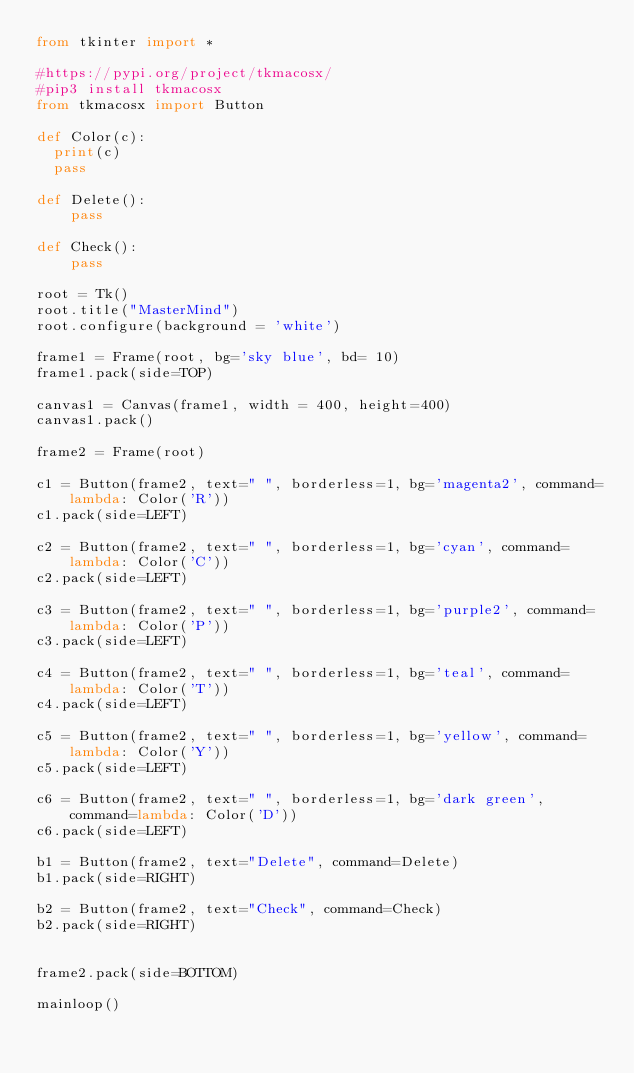<code> <loc_0><loc_0><loc_500><loc_500><_Python_>from tkinter import *

#https://pypi.org/project/tkmacosx/
#pip3 install tkmacosx
from tkmacosx import Button

def Color(c):
  print(c)
  pass

def Delete():
    pass

def Check():
    pass

root = Tk()
root.title("MasterMind")
root.configure(background = 'white')

frame1 = Frame(root, bg='sky blue', bd= 10)
frame1.pack(side=TOP)

canvas1 = Canvas(frame1, width = 400, height=400)
canvas1.pack()

frame2 = Frame(root)

c1 = Button(frame2, text=" ", borderless=1, bg='magenta2', command=lambda: Color('R'))
c1.pack(side=LEFT)

c2 = Button(frame2, text=" ", borderless=1, bg='cyan', command=lambda: Color('C'))
c2.pack(side=LEFT)

c3 = Button(frame2, text=" ", borderless=1, bg='purple2', command=lambda: Color('P'))
c3.pack(side=LEFT)

c4 = Button(frame2, text=" ", borderless=1, bg='teal', command=lambda: Color('T'))
c4.pack(side=LEFT)

c5 = Button(frame2, text=" ", borderless=1, bg='yellow', command=lambda: Color('Y'))
c5.pack(side=LEFT)

c6 = Button(frame2, text=" ", borderless=1, bg='dark green', command=lambda: Color('D'))
c6.pack(side=LEFT)

b1 = Button(frame2, text="Delete", command=Delete)
b1.pack(side=RIGHT)

b2 = Button(frame2, text="Check", command=Check)
b2.pack(side=RIGHT)


frame2.pack(side=BOTTOM)

mainloop()</code> 